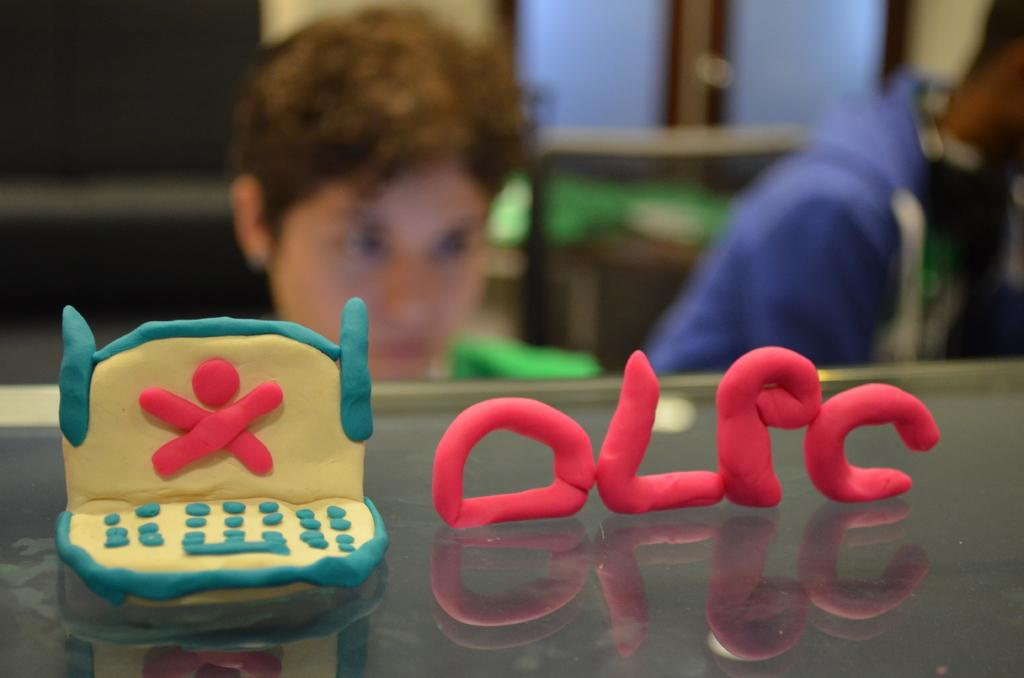Who or what is present in the image? There is a person in the image. What is the person wearing? The person is wearing clothes. What type of surface can be seen in the image? There is a glass surface in the image. What material is present in the image? There is clay in the image. How would you describe the background of the image? The background of the image is blurred. How many chairs are visible in the image? There are no chairs present in the image. What type of park is shown in the image? There is no park present in the image. 